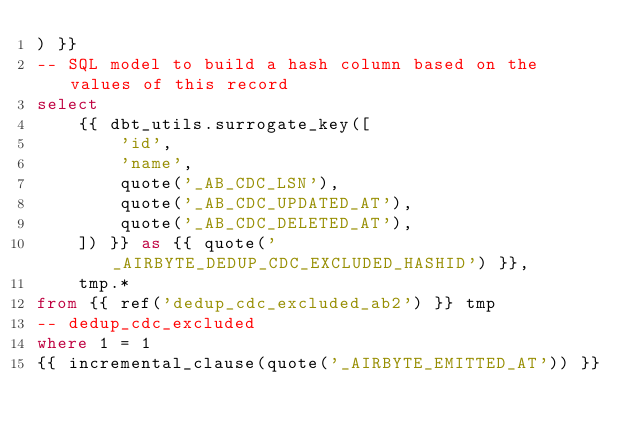<code> <loc_0><loc_0><loc_500><loc_500><_SQL_>) }}
-- SQL model to build a hash column based on the values of this record
select
    {{ dbt_utils.surrogate_key([
        'id',
        'name',
        quote('_AB_CDC_LSN'),
        quote('_AB_CDC_UPDATED_AT'),
        quote('_AB_CDC_DELETED_AT'),
    ]) }} as {{ quote('_AIRBYTE_DEDUP_CDC_EXCLUDED_HASHID') }},
    tmp.*
from {{ ref('dedup_cdc_excluded_ab2') }} tmp
-- dedup_cdc_excluded
where 1 = 1
{{ incremental_clause(quote('_AIRBYTE_EMITTED_AT')) }}

</code> 